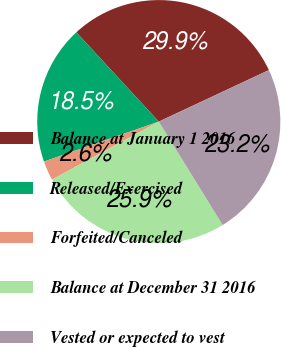<chart> <loc_0><loc_0><loc_500><loc_500><pie_chart><fcel>Balance at January 1 2016<fcel>Released/Exercised<fcel>Forfeited/Canceled<fcel>Balance at December 31 2016<fcel>Vested or expected to vest<nl><fcel>29.9%<fcel>18.46%<fcel>2.59%<fcel>25.89%<fcel>23.16%<nl></chart> 